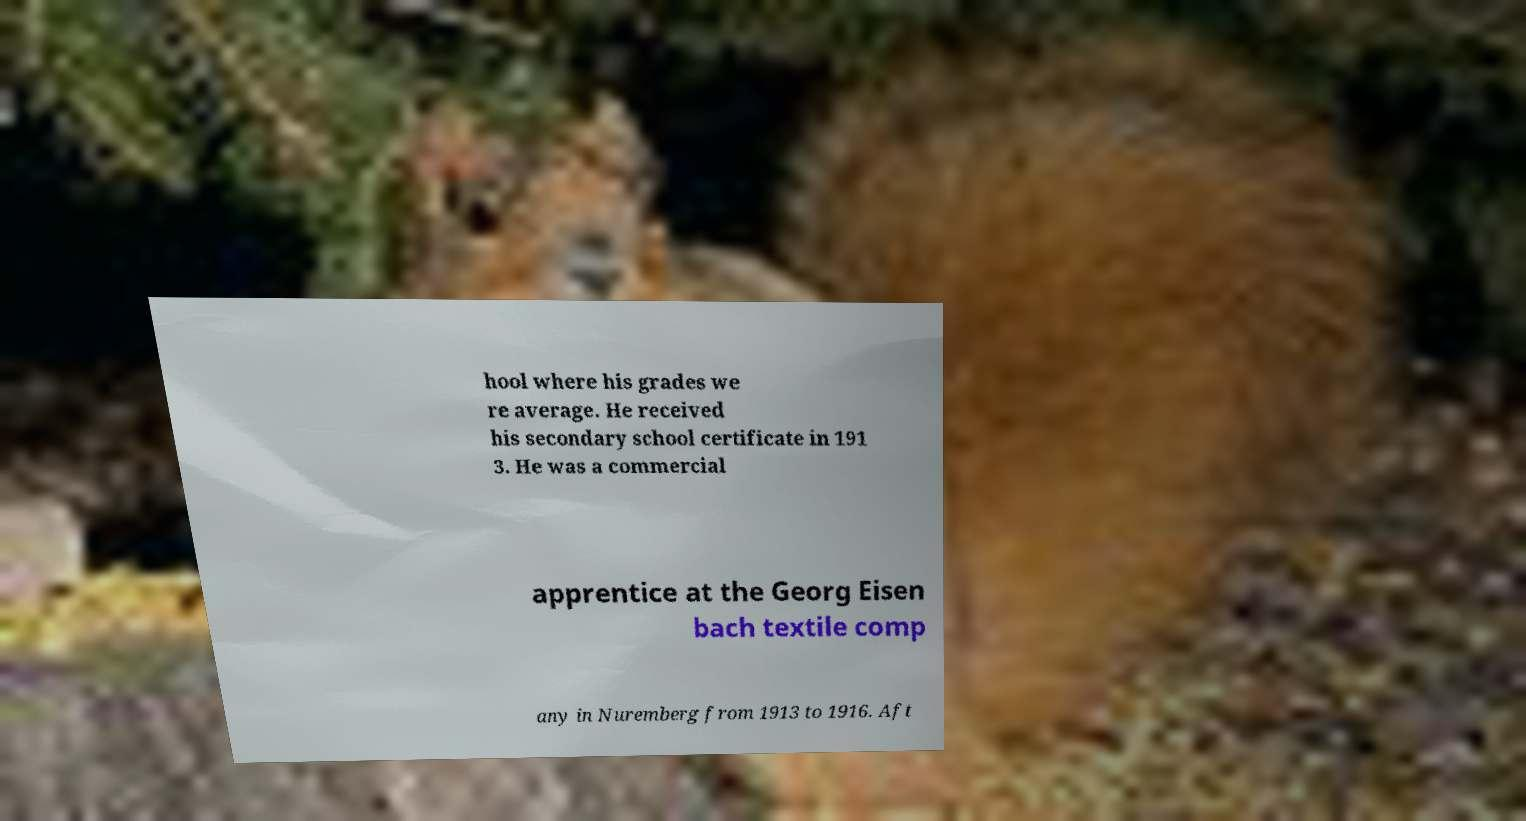Could you extract and type out the text from this image? hool where his grades we re average. He received his secondary school certificate in 191 3. He was a commercial apprentice at the Georg Eisen bach textile comp any in Nuremberg from 1913 to 1916. Aft 